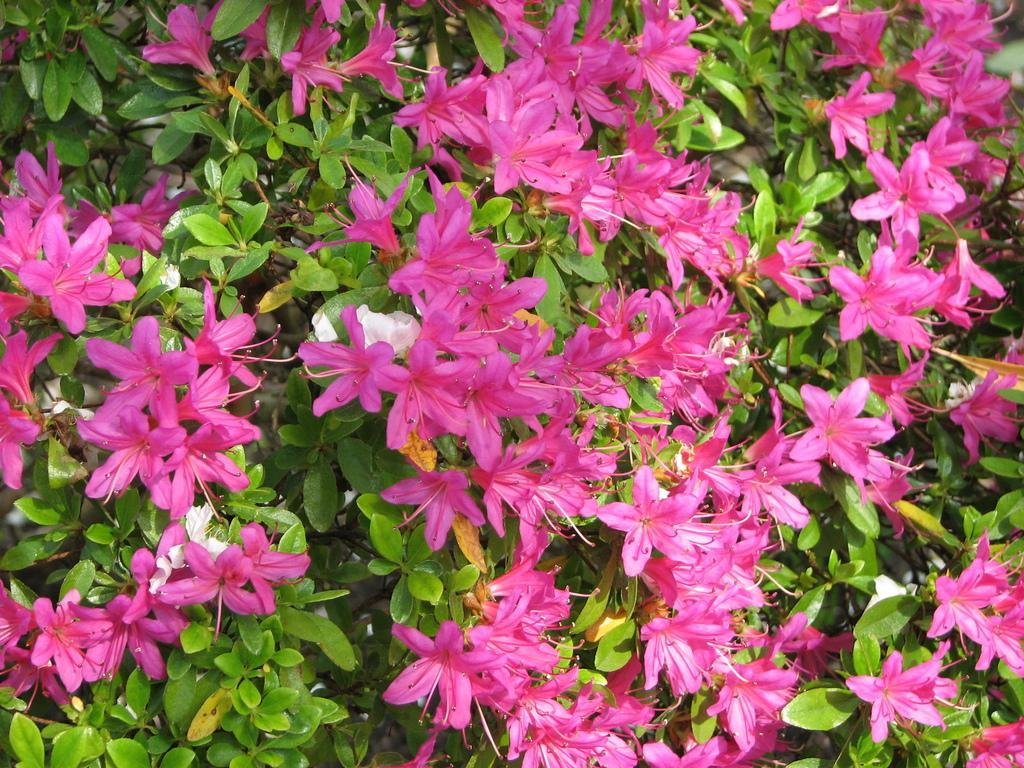Can you describe this image briefly? In this picture, we see plants or trees. These plants have flowers and these flowers are in pink color. 